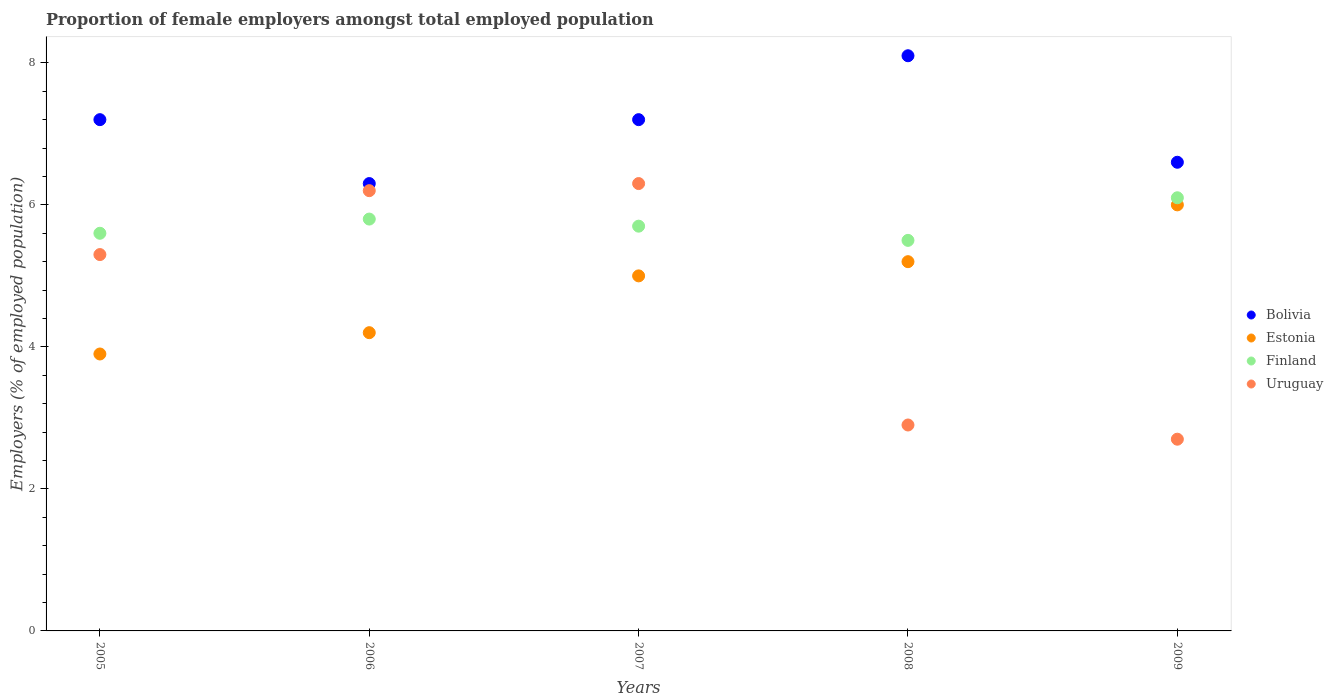How many different coloured dotlines are there?
Provide a succinct answer. 4. Is the number of dotlines equal to the number of legend labels?
Offer a terse response. Yes. What is the proportion of female employers in Bolivia in 2005?
Your answer should be compact. 7.2. Across all years, what is the maximum proportion of female employers in Bolivia?
Give a very brief answer. 8.1. Across all years, what is the minimum proportion of female employers in Finland?
Offer a terse response. 5.5. What is the total proportion of female employers in Finland in the graph?
Give a very brief answer. 28.7. What is the difference between the proportion of female employers in Finland in 2005 and that in 2009?
Keep it short and to the point. -0.5. What is the difference between the proportion of female employers in Estonia in 2008 and the proportion of female employers in Finland in 2007?
Offer a very short reply. -0.5. What is the average proportion of female employers in Uruguay per year?
Your response must be concise. 4.68. In the year 2007, what is the difference between the proportion of female employers in Uruguay and proportion of female employers in Estonia?
Ensure brevity in your answer.  1.3. In how many years, is the proportion of female employers in Bolivia greater than 2 %?
Provide a short and direct response. 5. What is the ratio of the proportion of female employers in Uruguay in 2005 to that in 2009?
Make the answer very short. 1.96. What is the difference between the highest and the second highest proportion of female employers in Uruguay?
Your answer should be compact. 0.1. What is the difference between the highest and the lowest proportion of female employers in Estonia?
Offer a very short reply. 2.1. Is it the case that in every year, the sum of the proportion of female employers in Uruguay and proportion of female employers in Bolivia  is greater than the sum of proportion of female employers in Finland and proportion of female employers in Estonia?
Your answer should be very brief. No. Is the proportion of female employers in Estonia strictly greater than the proportion of female employers in Bolivia over the years?
Your answer should be compact. No. How many dotlines are there?
Keep it short and to the point. 4. What is the difference between two consecutive major ticks on the Y-axis?
Provide a short and direct response. 2. Are the values on the major ticks of Y-axis written in scientific E-notation?
Keep it short and to the point. No. Does the graph contain grids?
Provide a short and direct response. No. How many legend labels are there?
Your answer should be very brief. 4. How are the legend labels stacked?
Offer a terse response. Vertical. What is the title of the graph?
Offer a terse response. Proportion of female employers amongst total employed population. What is the label or title of the Y-axis?
Ensure brevity in your answer.  Employers (% of employed population). What is the Employers (% of employed population) in Bolivia in 2005?
Offer a very short reply. 7.2. What is the Employers (% of employed population) in Estonia in 2005?
Your answer should be very brief. 3.9. What is the Employers (% of employed population) of Finland in 2005?
Make the answer very short. 5.6. What is the Employers (% of employed population) of Uruguay in 2005?
Your answer should be very brief. 5.3. What is the Employers (% of employed population) in Bolivia in 2006?
Your response must be concise. 6.3. What is the Employers (% of employed population) of Estonia in 2006?
Your answer should be compact. 4.2. What is the Employers (% of employed population) of Finland in 2006?
Your answer should be very brief. 5.8. What is the Employers (% of employed population) in Uruguay in 2006?
Make the answer very short. 6.2. What is the Employers (% of employed population) of Bolivia in 2007?
Your answer should be very brief. 7.2. What is the Employers (% of employed population) in Estonia in 2007?
Provide a short and direct response. 5. What is the Employers (% of employed population) in Finland in 2007?
Provide a succinct answer. 5.7. What is the Employers (% of employed population) in Uruguay in 2007?
Offer a terse response. 6.3. What is the Employers (% of employed population) in Bolivia in 2008?
Offer a very short reply. 8.1. What is the Employers (% of employed population) in Estonia in 2008?
Offer a very short reply. 5.2. What is the Employers (% of employed population) of Uruguay in 2008?
Offer a terse response. 2.9. What is the Employers (% of employed population) of Bolivia in 2009?
Your response must be concise. 6.6. What is the Employers (% of employed population) of Estonia in 2009?
Provide a succinct answer. 6. What is the Employers (% of employed population) of Finland in 2009?
Keep it short and to the point. 6.1. What is the Employers (% of employed population) in Uruguay in 2009?
Offer a terse response. 2.7. Across all years, what is the maximum Employers (% of employed population) of Bolivia?
Give a very brief answer. 8.1. Across all years, what is the maximum Employers (% of employed population) of Finland?
Make the answer very short. 6.1. Across all years, what is the maximum Employers (% of employed population) in Uruguay?
Provide a succinct answer. 6.3. Across all years, what is the minimum Employers (% of employed population) of Bolivia?
Your answer should be compact. 6.3. Across all years, what is the minimum Employers (% of employed population) of Estonia?
Make the answer very short. 3.9. Across all years, what is the minimum Employers (% of employed population) of Uruguay?
Provide a succinct answer. 2.7. What is the total Employers (% of employed population) of Bolivia in the graph?
Keep it short and to the point. 35.4. What is the total Employers (% of employed population) in Estonia in the graph?
Offer a very short reply. 24.3. What is the total Employers (% of employed population) in Finland in the graph?
Keep it short and to the point. 28.7. What is the total Employers (% of employed population) of Uruguay in the graph?
Provide a short and direct response. 23.4. What is the difference between the Employers (% of employed population) in Bolivia in 2005 and that in 2006?
Your response must be concise. 0.9. What is the difference between the Employers (% of employed population) in Bolivia in 2005 and that in 2007?
Offer a terse response. 0. What is the difference between the Employers (% of employed population) in Estonia in 2005 and that in 2007?
Keep it short and to the point. -1.1. What is the difference between the Employers (% of employed population) of Uruguay in 2005 and that in 2008?
Ensure brevity in your answer.  2.4. What is the difference between the Employers (% of employed population) of Estonia in 2005 and that in 2009?
Provide a short and direct response. -2.1. What is the difference between the Employers (% of employed population) in Finland in 2005 and that in 2009?
Keep it short and to the point. -0.5. What is the difference between the Employers (% of employed population) of Uruguay in 2005 and that in 2009?
Your answer should be compact. 2.6. What is the difference between the Employers (% of employed population) of Estonia in 2006 and that in 2007?
Keep it short and to the point. -0.8. What is the difference between the Employers (% of employed population) in Uruguay in 2006 and that in 2007?
Give a very brief answer. -0.1. What is the difference between the Employers (% of employed population) in Bolivia in 2006 and that in 2008?
Your answer should be very brief. -1.8. What is the difference between the Employers (% of employed population) in Uruguay in 2006 and that in 2008?
Offer a terse response. 3.3. What is the difference between the Employers (% of employed population) of Finland in 2007 and that in 2008?
Provide a short and direct response. 0.2. What is the difference between the Employers (% of employed population) in Bolivia in 2007 and that in 2009?
Give a very brief answer. 0.6. What is the difference between the Employers (% of employed population) of Estonia in 2007 and that in 2009?
Make the answer very short. -1. What is the difference between the Employers (% of employed population) in Finland in 2007 and that in 2009?
Ensure brevity in your answer.  -0.4. What is the difference between the Employers (% of employed population) in Estonia in 2008 and that in 2009?
Your answer should be very brief. -0.8. What is the difference between the Employers (% of employed population) of Finland in 2008 and that in 2009?
Your response must be concise. -0.6. What is the difference between the Employers (% of employed population) in Uruguay in 2008 and that in 2009?
Give a very brief answer. 0.2. What is the difference between the Employers (% of employed population) of Bolivia in 2005 and the Employers (% of employed population) of Uruguay in 2006?
Ensure brevity in your answer.  1. What is the difference between the Employers (% of employed population) of Estonia in 2005 and the Employers (% of employed population) of Finland in 2006?
Your response must be concise. -1.9. What is the difference between the Employers (% of employed population) of Finland in 2005 and the Employers (% of employed population) of Uruguay in 2006?
Your answer should be compact. -0.6. What is the difference between the Employers (% of employed population) in Estonia in 2005 and the Employers (% of employed population) in Finland in 2007?
Offer a very short reply. -1.8. What is the difference between the Employers (% of employed population) of Estonia in 2005 and the Employers (% of employed population) of Uruguay in 2007?
Ensure brevity in your answer.  -2.4. What is the difference between the Employers (% of employed population) in Finland in 2005 and the Employers (% of employed population) in Uruguay in 2007?
Ensure brevity in your answer.  -0.7. What is the difference between the Employers (% of employed population) of Bolivia in 2005 and the Employers (% of employed population) of Estonia in 2008?
Your answer should be very brief. 2. What is the difference between the Employers (% of employed population) of Bolivia in 2005 and the Employers (% of employed population) of Finland in 2008?
Your answer should be compact. 1.7. What is the difference between the Employers (% of employed population) of Bolivia in 2005 and the Employers (% of employed population) of Uruguay in 2008?
Your answer should be compact. 4.3. What is the difference between the Employers (% of employed population) of Estonia in 2005 and the Employers (% of employed population) of Finland in 2008?
Make the answer very short. -1.6. What is the difference between the Employers (% of employed population) in Estonia in 2005 and the Employers (% of employed population) in Uruguay in 2008?
Provide a succinct answer. 1. What is the difference between the Employers (% of employed population) of Finland in 2005 and the Employers (% of employed population) of Uruguay in 2008?
Your answer should be very brief. 2.7. What is the difference between the Employers (% of employed population) of Estonia in 2005 and the Employers (% of employed population) of Uruguay in 2009?
Keep it short and to the point. 1.2. What is the difference between the Employers (% of employed population) of Finland in 2005 and the Employers (% of employed population) of Uruguay in 2009?
Make the answer very short. 2.9. What is the difference between the Employers (% of employed population) of Bolivia in 2006 and the Employers (% of employed population) of Uruguay in 2007?
Your response must be concise. 0. What is the difference between the Employers (% of employed population) of Estonia in 2006 and the Employers (% of employed population) of Finland in 2007?
Provide a succinct answer. -1.5. What is the difference between the Employers (% of employed population) of Finland in 2006 and the Employers (% of employed population) of Uruguay in 2007?
Make the answer very short. -0.5. What is the difference between the Employers (% of employed population) in Bolivia in 2006 and the Employers (% of employed population) in Uruguay in 2008?
Ensure brevity in your answer.  3.4. What is the difference between the Employers (% of employed population) in Estonia in 2006 and the Employers (% of employed population) in Finland in 2008?
Offer a very short reply. -1.3. What is the difference between the Employers (% of employed population) in Estonia in 2006 and the Employers (% of employed population) in Uruguay in 2008?
Offer a terse response. 1.3. What is the difference between the Employers (% of employed population) in Finland in 2006 and the Employers (% of employed population) in Uruguay in 2008?
Offer a very short reply. 2.9. What is the difference between the Employers (% of employed population) in Bolivia in 2006 and the Employers (% of employed population) in Estonia in 2009?
Your answer should be very brief. 0.3. What is the difference between the Employers (% of employed population) of Bolivia in 2006 and the Employers (% of employed population) of Finland in 2009?
Make the answer very short. 0.2. What is the difference between the Employers (% of employed population) of Bolivia in 2006 and the Employers (% of employed population) of Uruguay in 2009?
Give a very brief answer. 3.6. What is the difference between the Employers (% of employed population) of Estonia in 2006 and the Employers (% of employed population) of Uruguay in 2009?
Make the answer very short. 1.5. What is the difference between the Employers (% of employed population) in Finland in 2006 and the Employers (% of employed population) in Uruguay in 2009?
Ensure brevity in your answer.  3.1. What is the difference between the Employers (% of employed population) of Bolivia in 2007 and the Employers (% of employed population) of Finland in 2008?
Your answer should be very brief. 1.7. What is the difference between the Employers (% of employed population) in Finland in 2007 and the Employers (% of employed population) in Uruguay in 2008?
Your response must be concise. 2.8. What is the difference between the Employers (% of employed population) of Bolivia in 2007 and the Employers (% of employed population) of Estonia in 2009?
Ensure brevity in your answer.  1.2. What is the difference between the Employers (% of employed population) of Estonia in 2007 and the Employers (% of employed population) of Finland in 2009?
Give a very brief answer. -1.1. What is the difference between the Employers (% of employed population) of Estonia in 2007 and the Employers (% of employed population) of Uruguay in 2009?
Keep it short and to the point. 2.3. What is the difference between the Employers (% of employed population) in Finland in 2007 and the Employers (% of employed population) in Uruguay in 2009?
Your response must be concise. 3. What is the difference between the Employers (% of employed population) in Bolivia in 2008 and the Employers (% of employed population) in Finland in 2009?
Keep it short and to the point. 2. What is the difference between the Employers (% of employed population) in Estonia in 2008 and the Employers (% of employed population) in Finland in 2009?
Make the answer very short. -0.9. What is the difference between the Employers (% of employed population) of Estonia in 2008 and the Employers (% of employed population) of Uruguay in 2009?
Your answer should be very brief. 2.5. What is the difference between the Employers (% of employed population) in Finland in 2008 and the Employers (% of employed population) in Uruguay in 2009?
Make the answer very short. 2.8. What is the average Employers (% of employed population) in Bolivia per year?
Provide a succinct answer. 7.08. What is the average Employers (% of employed population) in Estonia per year?
Your answer should be very brief. 4.86. What is the average Employers (% of employed population) of Finland per year?
Your response must be concise. 5.74. What is the average Employers (% of employed population) of Uruguay per year?
Provide a succinct answer. 4.68. In the year 2005, what is the difference between the Employers (% of employed population) of Bolivia and Employers (% of employed population) of Finland?
Offer a very short reply. 1.6. In the year 2005, what is the difference between the Employers (% of employed population) in Finland and Employers (% of employed population) in Uruguay?
Offer a very short reply. 0.3. In the year 2006, what is the difference between the Employers (% of employed population) of Estonia and Employers (% of employed population) of Finland?
Ensure brevity in your answer.  -1.6. In the year 2007, what is the difference between the Employers (% of employed population) in Bolivia and Employers (% of employed population) in Estonia?
Make the answer very short. 2.2. In the year 2007, what is the difference between the Employers (% of employed population) of Estonia and Employers (% of employed population) of Uruguay?
Offer a terse response. -1.3. In the year 2007, what is the difference between the Employers (% of employed population) of Finland and Employers (% of employed population) of Uruguay?
Make the answer very short. -0.6. In the year 2008, what is the difference between the Employers (% of employed population) of Estonia and Employers (% of employed population) of Finland?
Provide a short and direct response. -0.3. In the year 2008, what is the difference between the Employers (% of employed population) in Estonia and Employers (% of employed population) in Uruguay?
Keep it short and to the point. 2.3. In the year 2008, what is the difference between the Employers (% of employed population) of Finland and Employers (% of employed population) of Uruguay?
Give a very brief answer. 2.6. In the year 2009, what is the difference between the Employers (% of employed population) of Bolivia and Employers (% of employed population) of Estonia?
Ensure brevity in your answer.  0.6. In the year 2009, what is the difference between the Employers (% of employed population) in Bolivia and Employers (% of employed population) in Uruguay?
Provide a succinct answer. 3.9. In the year 2009, what is the difference between the Employers (% of employed population) of Estonia and Employers (% of employed population) of Finland?
Make the answer very short. -0.1. In the year 2009, what is the difference between the Employers (% of employed population) of Estonia and Employers (% of employed population) of Uruguay?
Make the answer very short. 3.3. What is the ratio of the Employers (% of employed population) in Estonia in 2005 to that in 2006?
Give a very brief answer. 0.93. What is the ratio of the Employers (% of employed population) in Finland in 2005 to that in 2006?
Offer a terse response. 0.97. What is the ratio of the Employers (% of employed population) in Uruguay in 2005 to that in 2006?
Make the answer very short. 0.85. What is the ratio of the Employers (% of employed population) in Estonia in 2005 to that in 2007?
Your response must be concise. 0.78. What is the ratio of the Employers (% of employed population) of Finland in 2005 to that in 2007?
Offer a terse response. 0.98. What is the ratio of the Employers (% of employed population) of Uruguay in 2005 to that in 2007?
Offer a terse response. 0.84. What is the ratio of the Employers (% of employed population) of Finland in 2005 to that in 2008?
Your answer should be very brief. 1.02. What is the ratio of the Employers (% of employed population) in Uruguay in 2005 to that in 2008?
Make the answer very short. 1.83. What is the ratio of the Employers (% of employed population) in Estonia in 2005 to that in 2009?
Offer a very short reply. 0.65. What is the ratio of the Employers (% of employed population) in Finland in 2005 to that in 2009?
Your response must be concise. 0.92. What is the ratio of the Employers (% of employed population) in Uruguay in 2005 to that in 2009?
Make the answer very short. 1.96. What is the ratio of the Employers (% of employed population) in Estonia in 2006 to that in 2007?
Provide a succinct answer. 0.84. What is the ratio of the Employers (% of employed population) in Finland in 2006 to that in 2007?
Ensure brevity in your answer.  1.02. What is the ratio of the Employers (% of employed population) in Uruguay in 2006 to that in 2007?
Offer a terse response. 0.98. What is the ratio of the Employers (% of employed population) of Bolivia in 2006 to that in 2008?
Offer a terse response. 0.78. What is the ratio of the Employers (% of employed population) of Estonia in 2006 to that in 2008?
Provide a succinct answer. 0.81. What is the ratio of the Employers (% of employed population) of Finland in 2006 to that in 2008?
Make the answer very short. 1.05. What is the ratio of the Employers (% of employed population) of Uruguay in 2006 to that in 2008?
Ensure brevity in your answer.  2.14. What is the ratio of the Employers (% of employed population) of Bolivia in 2006 to that in 2009?
Your response must be concise. 0.95. What is the ratio of the Employers (% of employed population) of Finland in 2006 to that in 2009?
Provide a short and direct response. 0.95. What is the ratio of the Employers (% of employed population) in Uruguay in 2006 to that in 2009?
Provide a succinct answer. 2.3. What is the ratio of the Employers (% of employed population) in Estonia in 2007 to that in 2008?
Provide a short and direct response. 0.96. What is the ratio of the Employers (% of employed population) in Finland in 2007 to that in 2008?
Your response must be concise. 1.04. What is the ratio of the Employers (% of employed population) in Uruguay in 2007 to that in 2008?
Keep it short and to the point. 2.17. What is the ratio of the Employers (% of employed population) of Estonia in 2007 to that in 2009?
Give a very brief answer. 0.83. What is the ratio of the Employers (% of employed population) of Finland in 2007 to that in 2009?
Offer a very short reply. 0.93. What is the ratio of the Employers (% of employed population) of Uruguay in 2007 to that in 2009?
Provide a succinct answer. 2.33. What is the ratio of the Employers (% of employed population) of Bolivia in 2008 to that in 2009?
Keep it short and to the point. 1.23. What is the ratio of the Employers (% of employed population) of Estonia in 2008 to that in 2009?
Provide a short and direct response. 0.87. What is the ratio of the Employers (% of employed population) in Finland in 2008 to that in 2009?
Make the answer very short. 0.9. What is the ratio of the Employers (% of employed population) in Uruguay in 2008 to that in 2009?
Your response must be concise. 1.07. What is the difference between the highest and the lowest Employers (% of employed population) of Bolivia?
Give a very brief answer. 1.8. What is the difference between the highest and the lowest Employers (% of employed population) in Uruguay?
Provide a succinct answer. 3.6. 